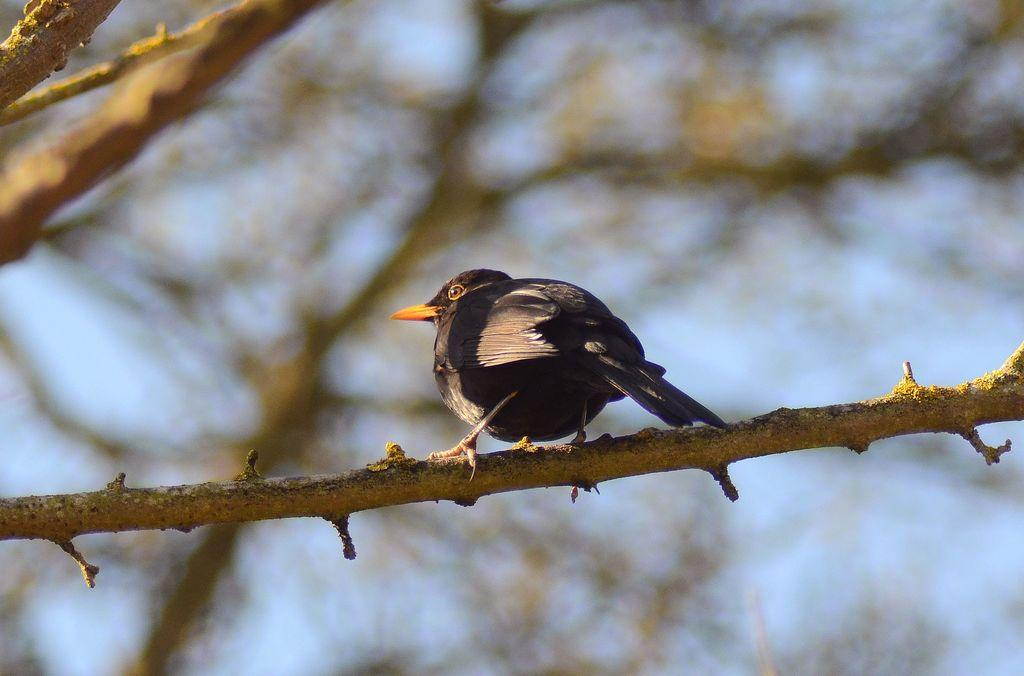What type of animal can be seen in the image? There is a bird in the image. Where is the bird located? The bird is standing on a branch of a tree. Can you describe the background of the image? The background of the image is blurry. Is the bird participating in any amusement activities in the image? There is no indication of any amusement activities in the image; the bird is simply standing on a branch of a tree. 